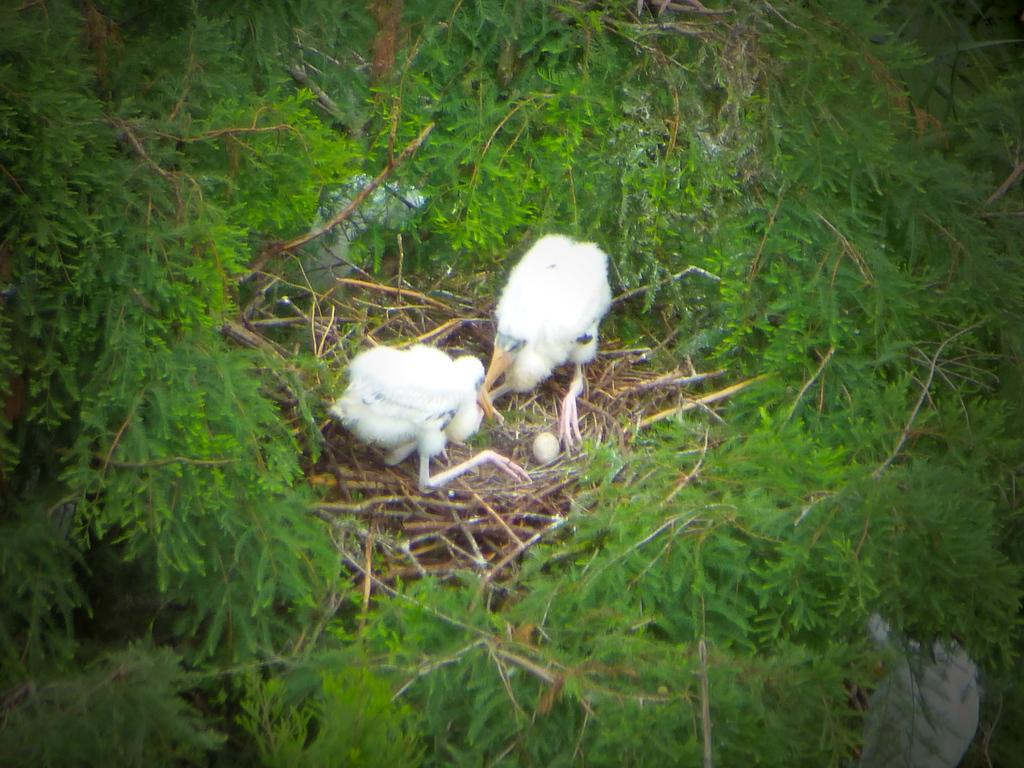What is the main subject in the center of the image? There is a nest in the center of the image. How many birds are in the nest? There are 2 white birds in the nest. What else can be found in the nest? There is an egg in the nest. What is visible around the nest? There are plants surrounding the nest. What type of book is being advertised in the image? There is no book or advertisement present in the image; it features a nest with birds and an egg. 